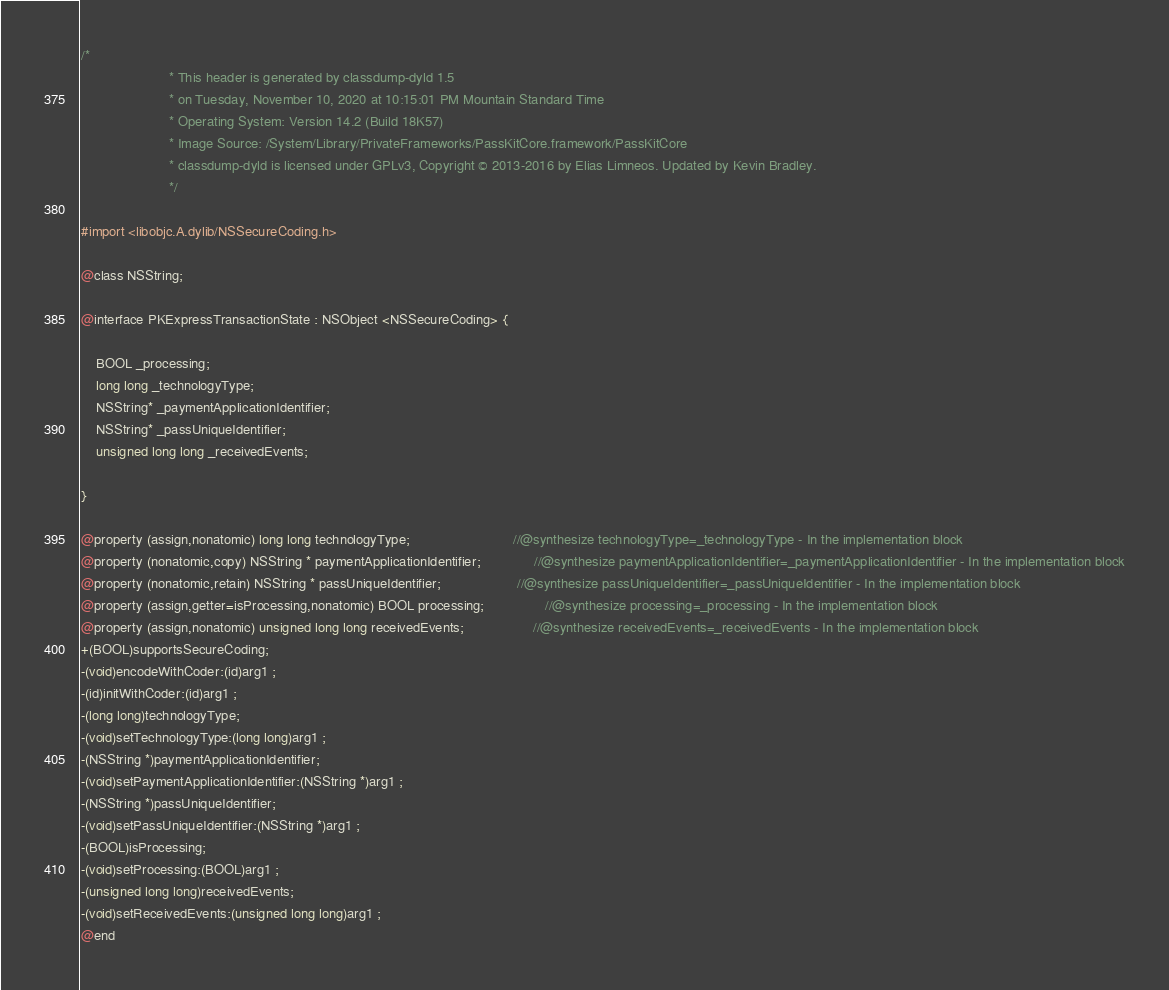<code> <loc_0><loc_0><loc_500><loc_500><_C_>/*
                       * This header is generated by classdump-dyld 1.5
                       * on Tuesday, November 10, 2020 at 10:15:01 PM Mountain Standard Time
                       * Operating System: Version 14.2 (Build 18K57)
                       * Image Source: /System/Library/PrivateFrameworks/PassKitCore.framework/PassKitCore
                       * classdump-dyld is licensed under GPLv3, Copyright © 2013-2016 by Elias Limneos. Updated by Kevin Bradley.
                       */

#import <libobjc.A.dylib/NSSecureCoding.h>

@class NSString;

@interface PKExpressTransactionState : NSObject <NSSecureCoding> {

	BOOL _processing;
	long long _technologyType;
	NSString* _paymentApplicationIdentifier;
	NSString* _passUniqueIdentifier;
	unsigned long long _receivedEvents;

}

@property (assign,nonatomic) long long technologyType;                           //@synthesize technologyType=_technologyType - In the implementation block
@property (nonatomic,copy) NSString * paymentApplicationIdentifier;              //@synthesize paymentApplicationIdentifier=_paymentApplicationIdentifier - In the implementation block
@property (nonatomic,retain) NSString * passUniqueIdentifier;                    //@synthesize passUniqueIdentifier=_passUniqueIdentifier - In the implementation block
@property (assign,getter=isProcessing,nonatomic) BOOL processing;                //@synthesize processing=_processing - In the implementation block
@property (assign,nonatomic) unsigned long long receivedEvents;                  //@synthesize receivedEvents=_receivedEvents - In the implementation block
+(BOOL)supportsSecureCoding;
-(void)encodeWithCoder:(id)arg1 ;
-(id)initWithCoder:(id)arg1 ;
-(long long)technologyType;
-(void)setTechnologyType:(long long)arg1 ;
-(NSString *)paymentApplicationIdentifier;
-(void)setPaymentApplicationIdentifier:(NSString *)arg1 ;
-(NSString *)passUniqueIdentifier;
-(void)setPassUniqueIdentifier:(NSString *)arg1 ;
-(BOOL)isProcessing;
-(void)setProcessing:(BOOL)arg1 ;
-(unsigned long long)receivedEvents;
-(void)setReceivedEvents:(unsigned long long)arg1 ;
@end

</code> 